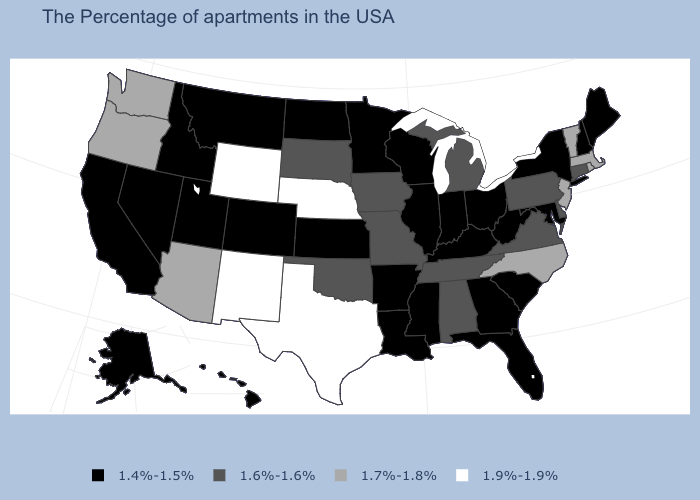Which states hav the highest value in the Northeast?
Write a very short answer. Massachusetts, Rhode Island, Vermont, New Jersey. Among the states that border North Dakota , which have the lowest value?
Quick response, please. Minnesota, Montana. Does the first symbol in the legend represent the smallest category?
Short answer required. Yes. What is the value of Rhode Island?
Short answer required. 1.7%-1.8%. What is the lowest value in the USA?
Keep it brief. 1.4%-1.5%. What is the value of Alabama?
Keep it brief. 1.6%-1.6%. Which states have the lowest value in the Northeast?
Short answer required. Maine, New Hampshire, New York. What is the highest value in the USA?
Short answer required. 1.9%-1.9%. Which states have the highest value in the USA?
Concise answer only. Nebraska, Texas, Wyoming, New Mexico. Among the states that border Oregon , which have the highest value?
Write a very short answer. Washington. Does the first symbol in the legend represent the smallest category?
Give a very brief answer. Yes. Name the states that have a value in the range 1.9%-1.9%?
Answer briefly. Nebraska, Texas, Wyoming, New Mexico. Does Nevada have the lowest value in the West?
Short answer required. Yes. What is the value of Maryland?
Give a very brief answer. 1.4%-1.5%. 